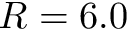Convert formula to latex. <formula><loc_0><loc_0><loc_500><loc_500>R = 6 . 0</formula> 